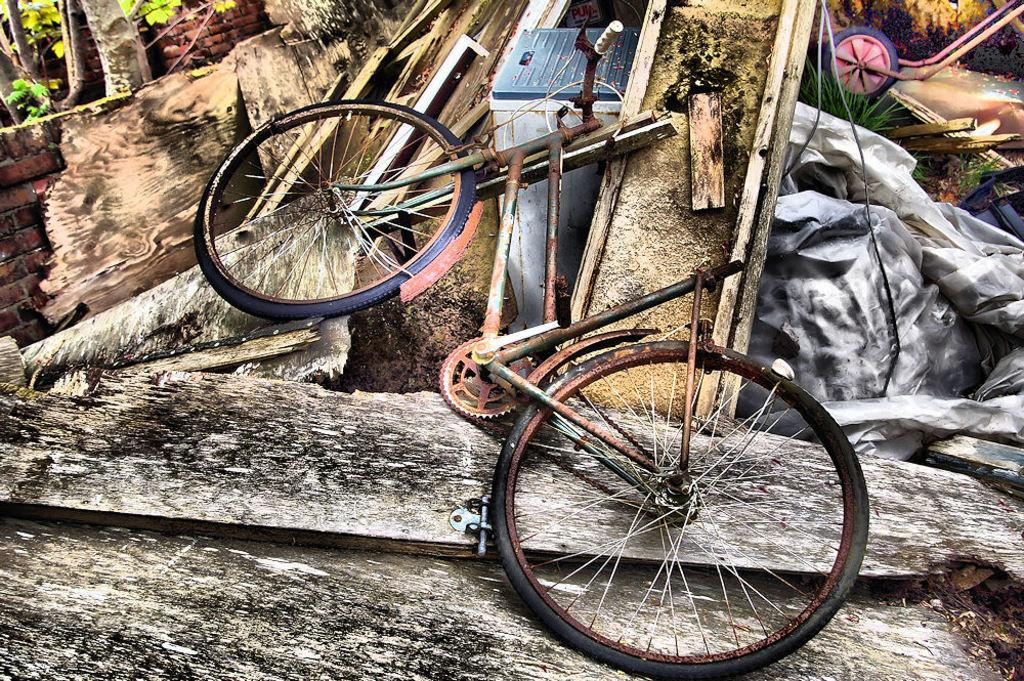What is the main object in the picture? There is a bicycle in the picture. What type of natural environment is depicted in the picture? There is grass, leaves, and tree trunks visible in the picture. Are there any other objects in the picture besides the bicycle? Yes, there are other objects in the picture. What type of trouble is the owl causing in the picture? There is no owl present in the picture, so it cannot be causing any trouble. 